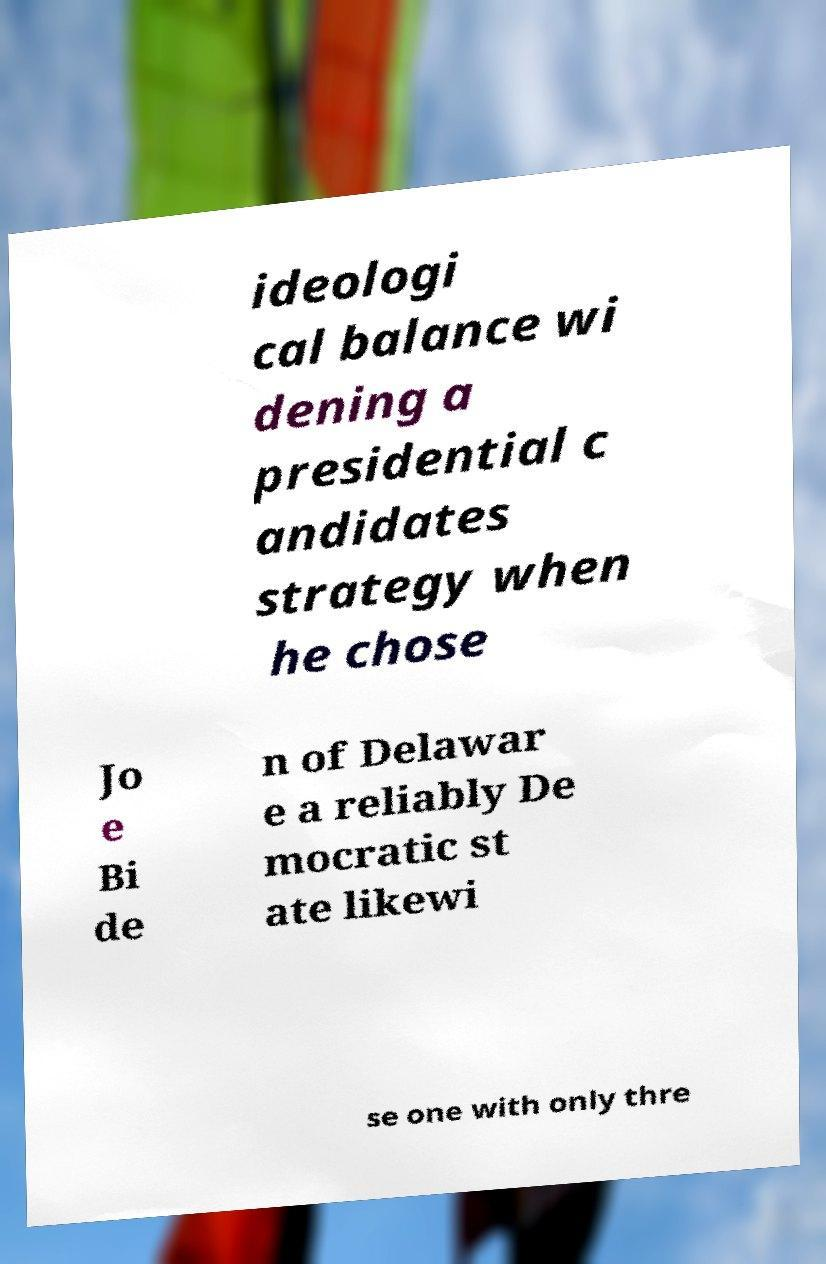I need the written content from this picture converted into text. Can you do that? ideologi cal balance wi dening a presidential c andidates strategy when he chose Jo e Bi de n of Delawar e a reliably De mocratic st ate likewi se one with only thre 